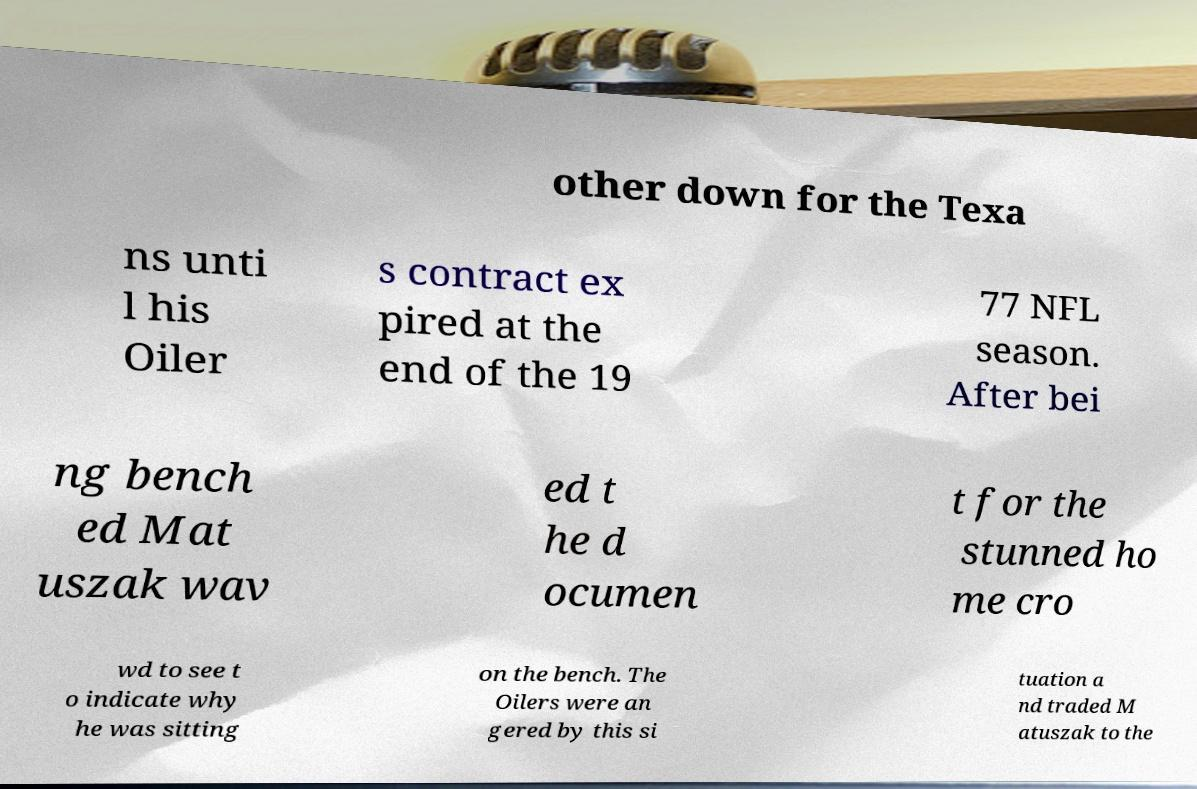Could you extract and type out the text from this image? other down for the Texa ns unti l his Oiler s contract ex pired at the end of the 19 77 NFL season. After bei ng bench ed Mat uszak wav ed t he d ocumen t for the stunned ho me cro wd to see t o indicate why he was sitting on the bench. The Oilers were an gered by this si tuation a nd traded M atuszak to the 